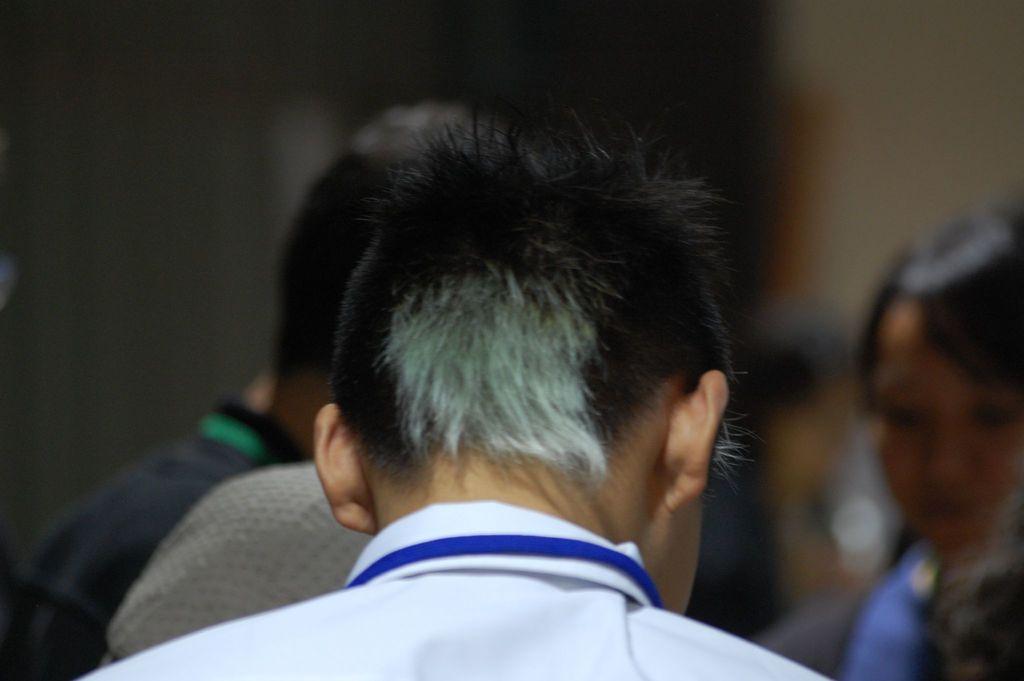In one or two sentences, can you explain what this image depicts? In the picture I can see a person wearing white color shirt is having a grey and black color hair and turned to back. The background of the image is dark and blurred, where we can see a few more people. 